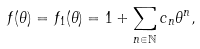Convert formula to latex. <formula><loc_0><loc_0><loc_500><loc_500>f ( \theta ) = f _ { 1 } ( \theta ) = 1 + \sum _ { n \in \mathbb { N } } c _ { n } \theta ^ { n } ,</formula> 